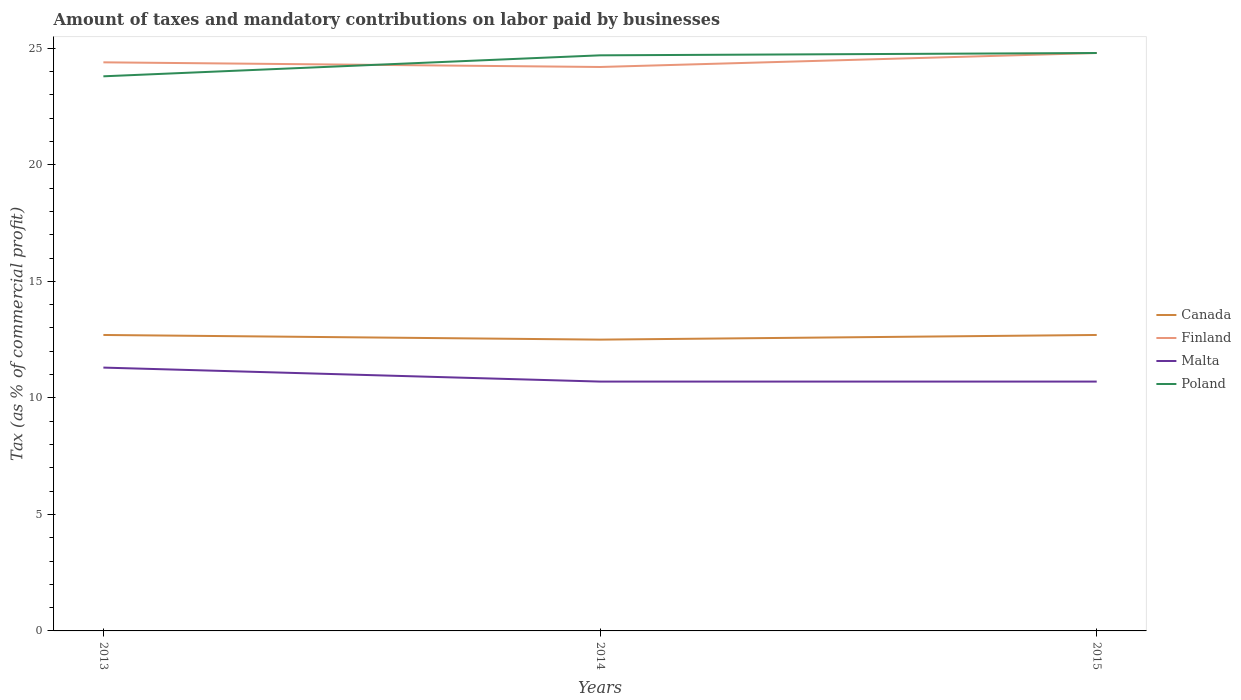Does the line corresponding to Canada intersect with the line corresponding to Poland?
Your answer should be very brief. No. Is the number of lines equal to the number of legend labels?
Make the answer very short. Yes. Across all years, what is the maximum percentage of taxes paid by businesses in Finland?
Your answer should be compact. 24.2. In which year was the percentage of taxes paid by businesses in Malta maximum?
Provide a succinct answer. 2014. What is the total percentage of taxes paid by businesses in Malta in the graph?
Your response must be concise. 0.6. What is the difference between the highest and the second highest percentage of taxes paid by businesses in Malta?
Offer a very short reply. 0.6. Is the percentage of taxes paid by businesses in Finland strictly greater than the percentage of taxes paid by businesses in Malta over the years?
Provide a short and direct response. No. Are the values on the major ticks of Y-axis written in scientific E-notation?
Make the answer very short. No. Does the graph contain any zero values?
Ensure brevity in your answer.  No. Does the graph contain grids?
Your answer should be very brief. No. Where does the legend appear in the graph?
Your answer should be very brief. Center right. How many legend labels are there?
Provide a short and direct response. 4. How are the legend labels stacked?
Your answer should be compact. Vertical. What is the title of the graph?
Your answer should be compact. Amount of taxes and mandatory contributions on labor paid by businesses. What is the label or title of the Y-axis?
Your answer should be compact. Tax (as % of commercial profit). What is the Tax (as % of commercial profit) in Finland in 2013?
Give a very brief answer. 24.4. What is the Tax (as % of commercial profit) of Poland in 2013?
Offer a terse response. 23.8. What is the Tax (as % of commercial profit) in Finland in 2014?
Keep it short and to the point. 24.2. What is the Tax (as % of commercial profit) of Poland in 2014?
Ensure brevity in your answer.  24.7. What is the Tax (as % of commercial profit) in Finland in 2015?
Provide a succinct answer. 24.8. What is the Tax (as % of commercial profit) of Malta in 2015?
Your answer should be very brief. 10.7. What is the Tax (as % of commercial profit) in Poland in 2015?
Keep it short and to the point. 24.8. Across all years, what is the maximum Tax (as % of commercial profit) in Finland?
Offer a very short reply. 24.8. Across all years, what is the maximum Tax (as % of commercial profit) of Poland?
Provide a short and direct response. 24.8. Across all years, what is the minimum Tax (as % of commercial profit) in Finland?
Offer a very short reply. 24.2. Across all years, what is the minimum Tax (as % of commercial profit) in Malta?
Give a very brief answer. 10.7. Across all years, what is the minimum Tax (as % of commercial profit) in Poland?
Offer a terse response. 23.8. What is the total Tax (as % of commercial profit) in Canada in the graph?
Make the answer very short. 37.9. What is the total Tax (as % of commercial profit) of Finland in the graph?
Offer a terse response. 73.4. What is the total Tax (as % of commercial profit) in Malta in the graph?
Your response must be concise. 32.7. What is the total Tax (as % of commercial profit) in Poland in the graph?
Your answer should be very brief. 73.3. What is the difference between the Tax (as % of commercial profit) of Canada in 2013 and that in 2014?
Your response must be concise. 0.2. What is the difference between the Tax (as % of commercial profit) of Finland in 2013 and that in 2014?
Ensure brevity in your answer.  0.2. What is the difference between the Tax (as % of commercial profit) in Poland in 2013 and that in 2014?
Provide a succinct answer. -0.9. What is the difference between the Tax (as % of commercial profit) of Canada in 2013 and that in 2015?
Your answer should be very brief. 0. What is the difference between the Tax (as % of commercial profit) of Poland in 2013 and that in 2015?
Your answer should be very brief. -1. What is the difference between the Tax (as % of commercial profit) of Canada in 2014 and that in 2015?
Ensure brevity in your answer.  -0.2. What is the difference between the Tax (as % of commercial profit) of Canada in 2013 and the Tax (as % of commercial profit) of Malta in 2014?
Offer a very short reply. 2. What is the difference between the Tax (as % of commercial profit) of Canada in 2013 and the Tax (as % of commercial profit) of Poland in 2014?
Make the answer very short. -12. What is the difference between the Tax (as % of commercial profit) of Finland in 2013 and the Tax (as % of commercial profit) of Poland in 2014?
Your answer should be compact. -0.3. What is the difference between the Tax (as % of commercial profit) of Canada in 2013 and the Tax (as % of commercial profit) of Malta in 2015?
Make the answer very short. 2. What is the difference between the Tax (as % of commercial profit) of Finland in 2013 and the Tax (as % of commercial profit) of Malta in 2015?
Provide a short and direct response. 13.7. What is the difference between the Tax (as % of commercial profit) of Finland in 2013 and the Tax (as % of commercial profit) of Poland in 2015?
Your answer should be compact. -0.4. What is the difference between the Tax (as % of commercial profit) of Canada in 2014 and the Tax (as % of commercial profit) of Finland in 2015?
Make the answer very short. -12.3. What is the difference between the Tax (as % of commercial profit) of Finland in 2014 and the Tax (as % of commercial profit) of Malta in 2015?
Your answer should be very brief. 13.5. What is the difference between the Tax (as % of commercial profit) in Malta in 2014 and the Tax (as % of commercial profit) in Poland in 2015?
Give a very brief answer. -14.1. What is the average Tax (as % of commercial profit) of Canada per year?
Your answer should be very brief. 12.63. What is the average Tax (as % of commercial profit) of Finland per year?
Your answer should be compact. 24.47. What is the average Tax (as % of commercial profit) of Poland per year?
Give a very brief answer. 24.43. In the year 2013, what is the difference between the Tax (as % of commercial profit) in Canada and Tax (as % of commercial profit) in Malta?
Give a very brief answer. 1.4. In the year 2013, what is the difference between the Tax (as % of commercial profit) in Canada and Tax (as % of commercial profit) in Poland?
Ensure brevity in your answer.  -11.1. In the year 2013, what is the difference between the Tax (as % of commercial profit) of Finland and Tax (as % of commercial profit) of Poland?
Ensure brevity in your answer.  0.6. In the year 2013, what is the difference between the Tax (as % of commercial profit) in Malta and Tax (as % of commercial profit) in Poland?
Your answer should be very brief. -12.5. In the year 2014, what is the difference between the Tax (as % of commercial profit) of Canada and Tax (as % of commercial profit) of Finland?
Your answer should be compact. -11.7. In the year 2014, what is the difference between the Tax (as % of commercial profit) of Finland and Tax (as % of commercial profit) of Malta?
Provide a short and direct response. 13.5. In the year 2015, what is the difference between the Tax (as % of commercial profit) in Canada and Tax (as % of commercial profit) in Finland?
Ensure brevity in your answer.  -12.1. In the year 2015, what is the difference between the Tax (as % of commercial profit) in Canada and Tax (as % of commercial profit) in Malta?
Provide a succinct answer. 2. In the year 2015, what is the difference between the Tax (as % of commercial profit) in Malta and Tax (as % of commercial profit) in Poland?
Offer a terse response. -14.1. What is the ratio of the Tax (as % of commercial profit) of Finland in 2013 to that in 2014?
Provide a short and direct response. 1.01. What is the ratio of the Tax (as % of commercial profit) of Malta in 2013 to that in 2014?
Offer a terse response. 1.06. What is the ratio of the Tax (as % of commercial profit) in Poland in 2013 to that in 2014?
Your answer should be compact. 0.96. What is the ratio of the Tax (as % of commercial profit) of Finland in 2013 to that in 2015?
Your answer should be very brief. 0.98. What is the ratio of the Tax (as % of commercial profit) in Malta in 2013 to that in 2015?
Your answer should be very brief. 1.06. What is the ratio of the Tax (as % of commercial profit) in Poland in 2013 to that in 2015?
Your answer should be compact. 0.96. What is the ratio of the Tax (as % of commercial profit) of Canada in 2014 to that in 2015?
Provide a short and direct response. 0.98. What is the ratio of the Tax (as % of commercial profit) in Finland in 2014 to that in 2015?
Your response must be concise. 0.98. What is the ratio of the Tax (as % of commercial profit) in Malta in 2014 to that in 2015?
Your response must be concise. 1. What is the difference between the highest and the second highest Tax (as % of commercial profit) of Finland?
Provide a succinct answer. 0.4. What is the difference between the highest and the lowest Tax (as % of commercial profit) of Canada?
Offer a terse response. 0.2. 